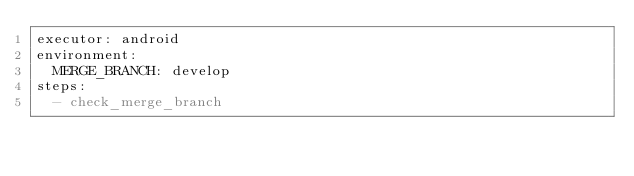<code> <loc_0><loc_0><loc_500><loc_500><_YAML_>executor: android
environment:
  MERGE_BRANCH: develop
steps:
  - check_merge_branch
</code> 